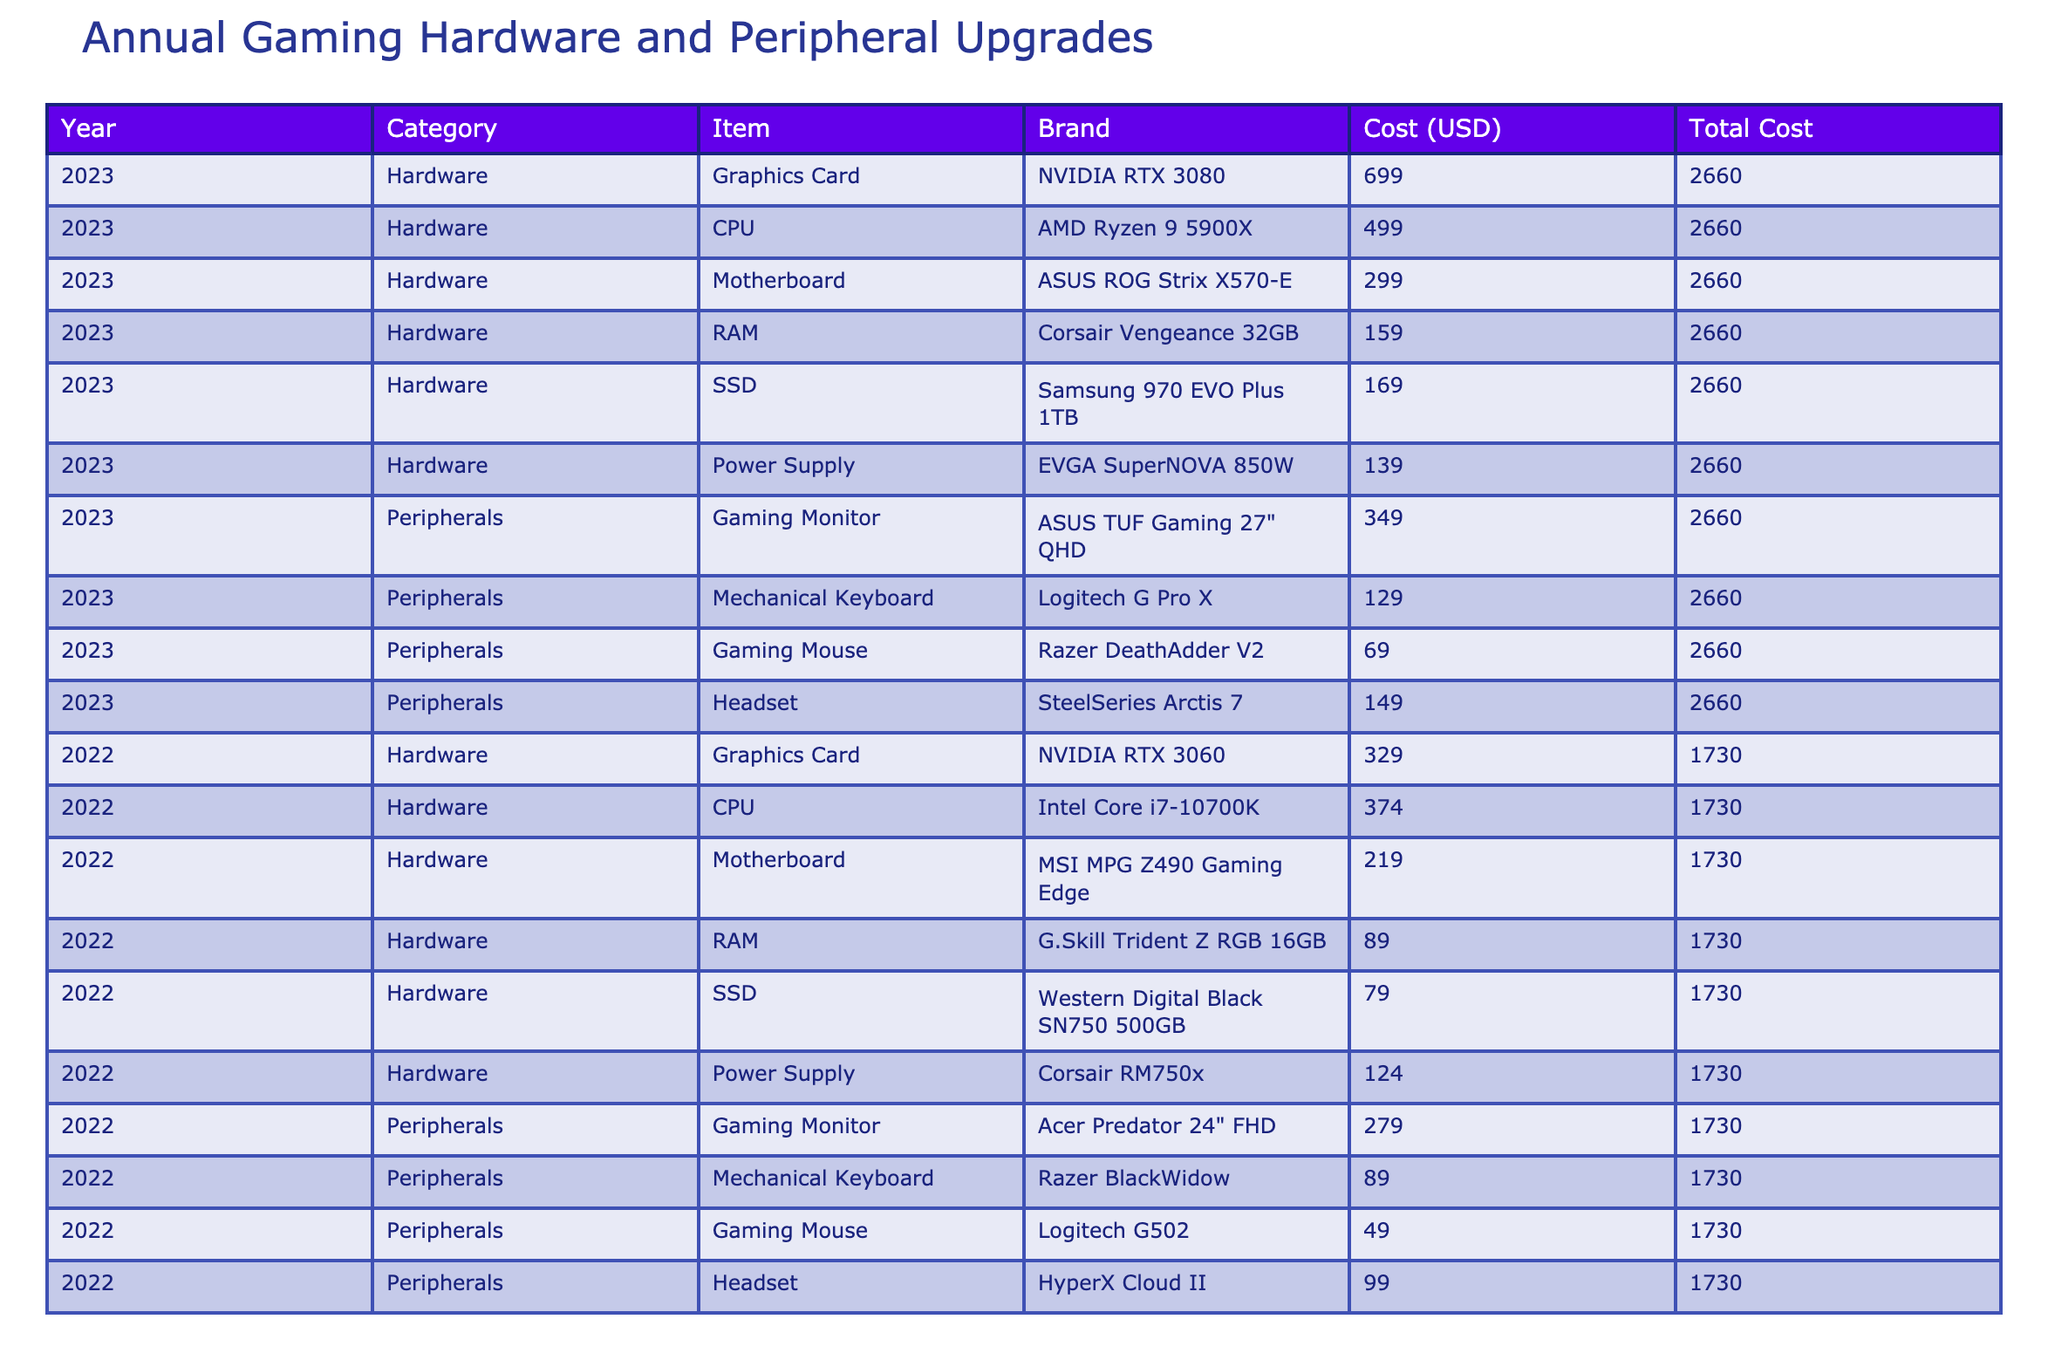What was the total cost of gaming hardware in 2023? To find this, we look at the "Total Cost" column for the year 2023. Summing the costs of all items in that year gives us: 699 + 499 + 299 + 159 + 169 + 139 + 349 + 129 + 69 + 149 = 2,192 USD
Answer: 2,192 USD Which gaming monitor was more expensive in 2022, and by how much? In 2022, there are two gaming monitors listed: "Acer Predator 24" FHD" costing 279 USD and "ASUS TUF Gaming 27" QHD" in 2023 costing 349 USD. The difference is calculated as 349 - 279 = 70 USD.
Answer: 349 USD; 70 USD Is the cost of upgrading the CPU in 2023 higher than in 2022? The CPU cost for 2023 is 499 USD for the AMD Ryzen 9 5900X, while for 2022 it is 374 USD for the Intel Core i7-10700K. Since 499 > 374, the cost is indeed higher in 2023.
Answer: Yes What is the total expenditure on peripherals for both years combined? To find this, we need to sum the costs of all peripherals listed for both years. In 2023: 349 + 129 + 69 + 149 = 696 USD. In 2022: 279 + 89 + 49 + 99 = 516 USD. Combining them gives 696 + 516 = 1,212 USD.
Answer: 1,212 USD Which year had a higher total expenditure on gaming hardware, and by how much? The total cost for gaming hardware in 2022 is 1,265 USD (329 + 374 + 219 + 89 + 79 + 124) and in 2023, it is 1,192 USD. The difference is 1,265 - 1,192 = 73 USD, so 2022 had a higher expenditure.
Answer: 2022; 73 USD Was the Razer DeathAdder V2 the cheapest gaming mouse in 2022? In 2022, the cost of the Razer DeathAdder V2 is 49 USD, while the Logitech G502 costs 49 USD, and the cheapest among the peripherals that year is still the same price. Thus, it is not cheaper than others.
Answer: No What percentage of the total expenditure in 2023 was spent on peripherals? The total expenditure in 2023 is 2,192 USD with peripherals costing 696 USD. To find the percentage: (696 / 2,192) * 100 = 31.7%.
Answer: 31.7% In which year did the total cost reach its peak, and what was that peak value? Comparing the total costs for both years: 2022's total cost is 1,265 USD, and 2023's total cost is 2,192 USD. The peak value is clearly in 2023.
Answer: 2023; 2,192 USD 